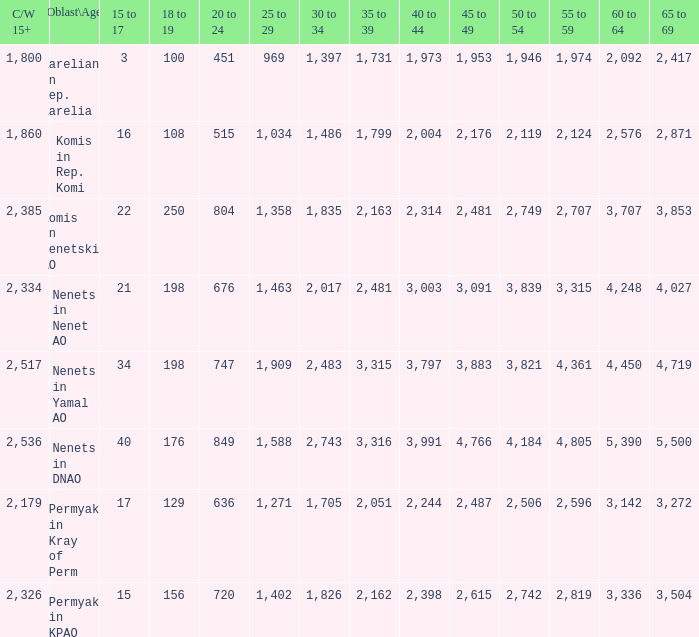What is the aggregate 60 to 64 when the oblast\age is nenets in yamal ao, and the 45 to 49 surpasses 3,883? None. 